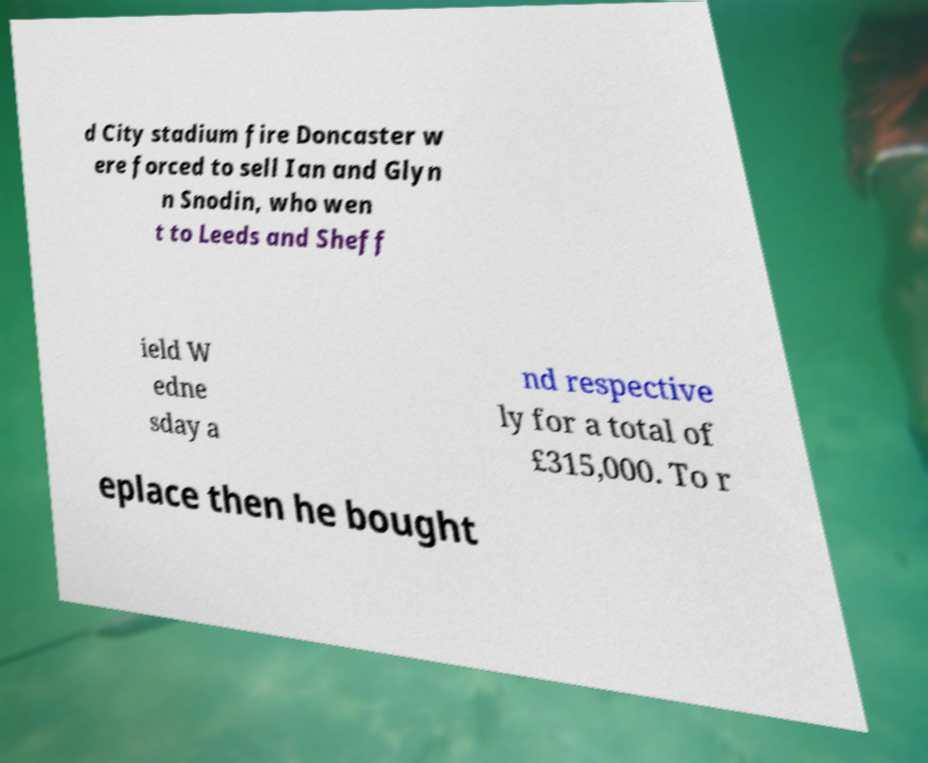Please read and relay the text visible in this image. What does it say? d City stadium fire Doncaster w ere forced to sell Ian and Glyn n Snodin, who wen t to Leeds and Sheff ield W edne sday a nd respective ly for a total of £315,000. To r eplace then he bought 